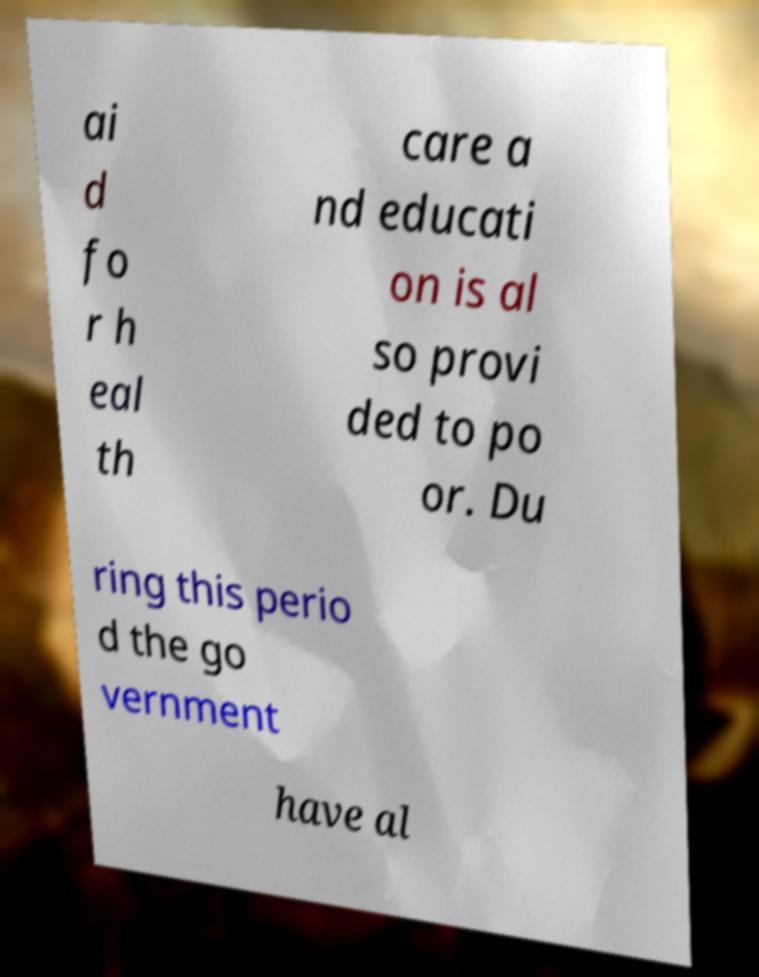For documentation purposes, I need the text within this image transcribed. Could you provide that? ai d fo r h eal th care a nd educati on is al so provi ded to po or. Du ring this perio d the go vernment have al 